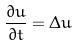<formula> <loc_0><loc_0><loc_500><loc_500>\frac { \partial u } { \partial t } = \Delta u</formula> 